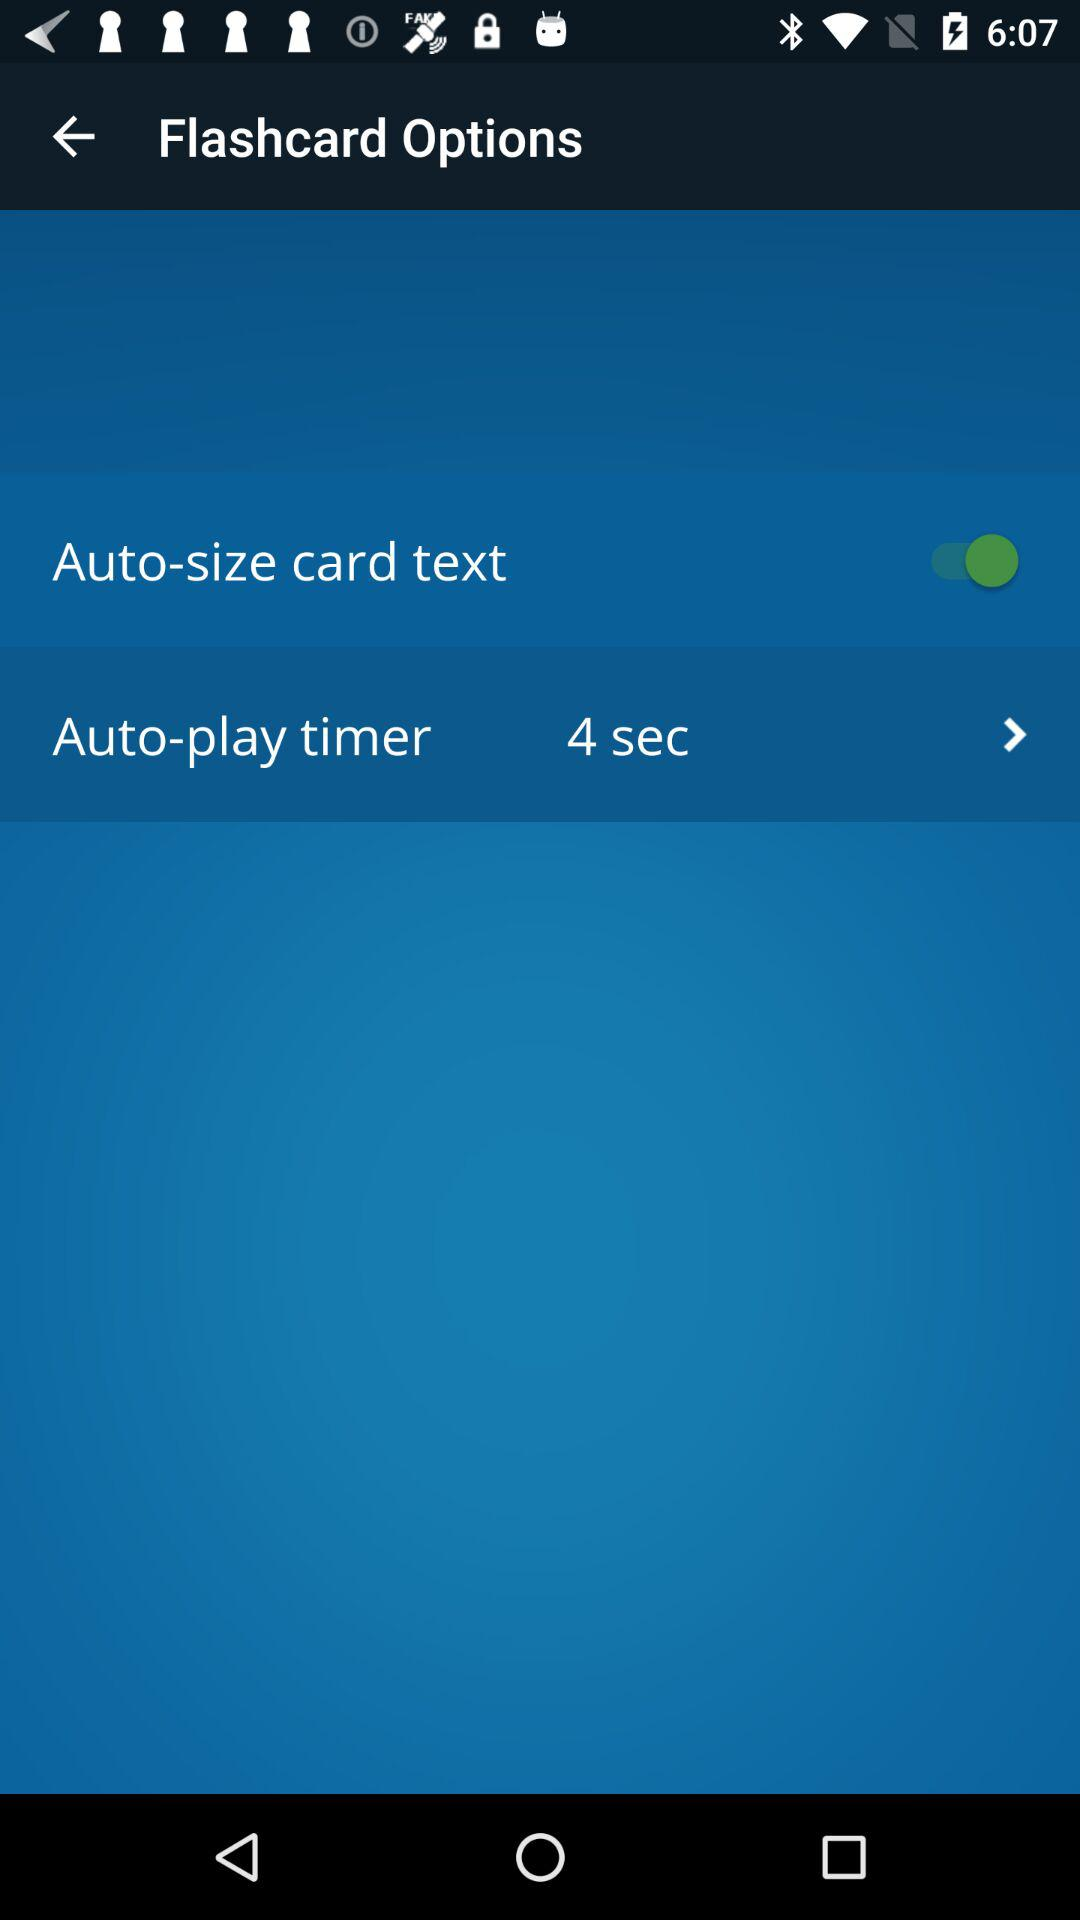How many seconds is the auto-play timer set to?
Answer the question using a single word or phrase. 4 